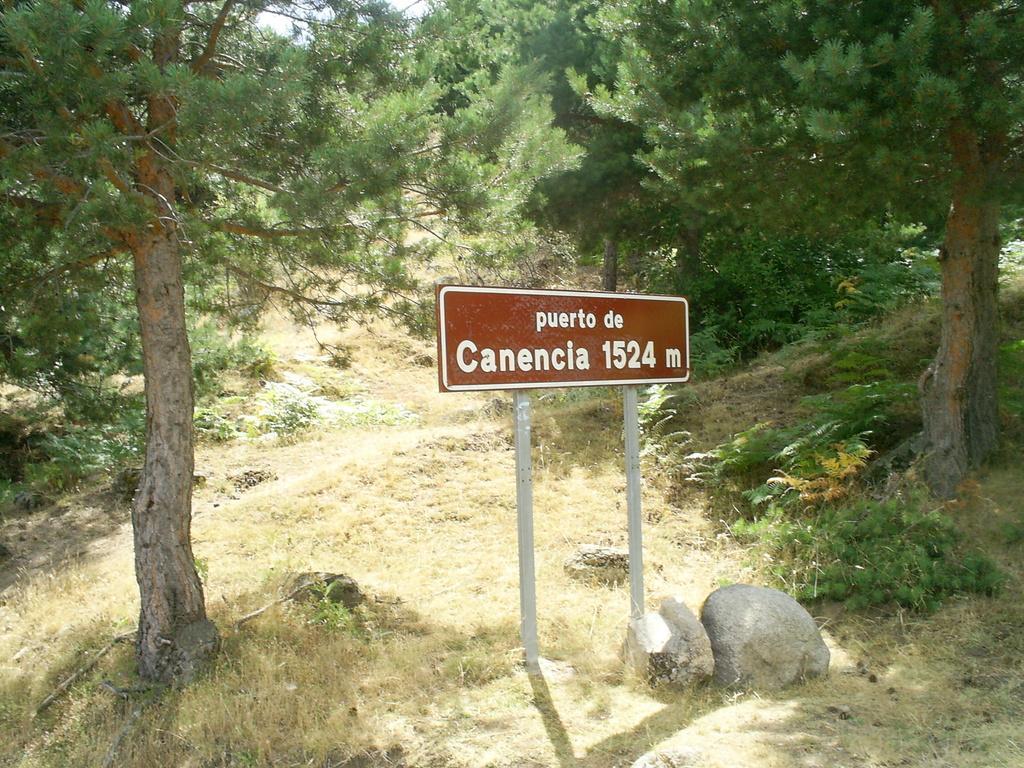In one or two sentences, can you explain what this image depicts? In this image, we can see a name board with poles. Here we can see few stones, grass, plants and trees. 